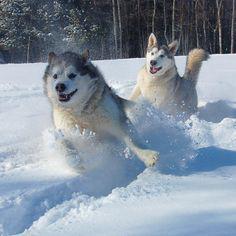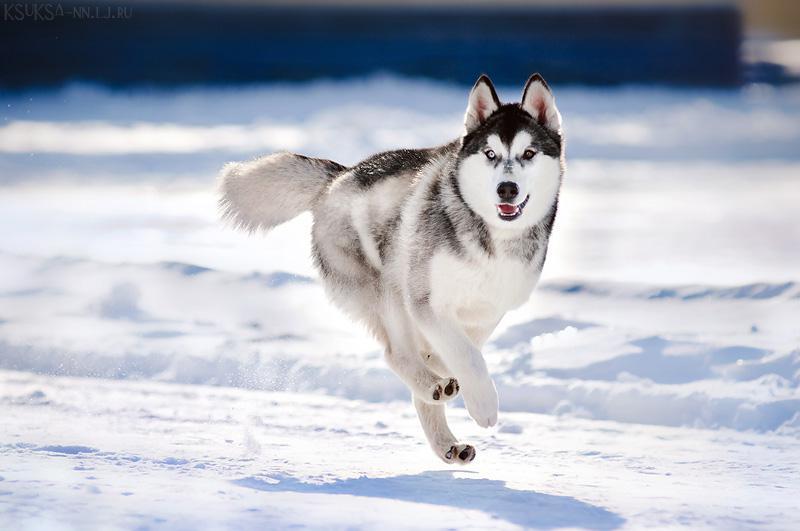The first image is the image on the left, the second image is the image on the right. Assess this claim about the two images: "There are four animals.". Correct or not? Answer yes or no. No. The first image is the image on the left, the second image is the image on the right. Given the left and right images, does the statement "At least one of the images shows a dog interacting with a mammal that is not a dog." hold true? Answer yes or no. No. 